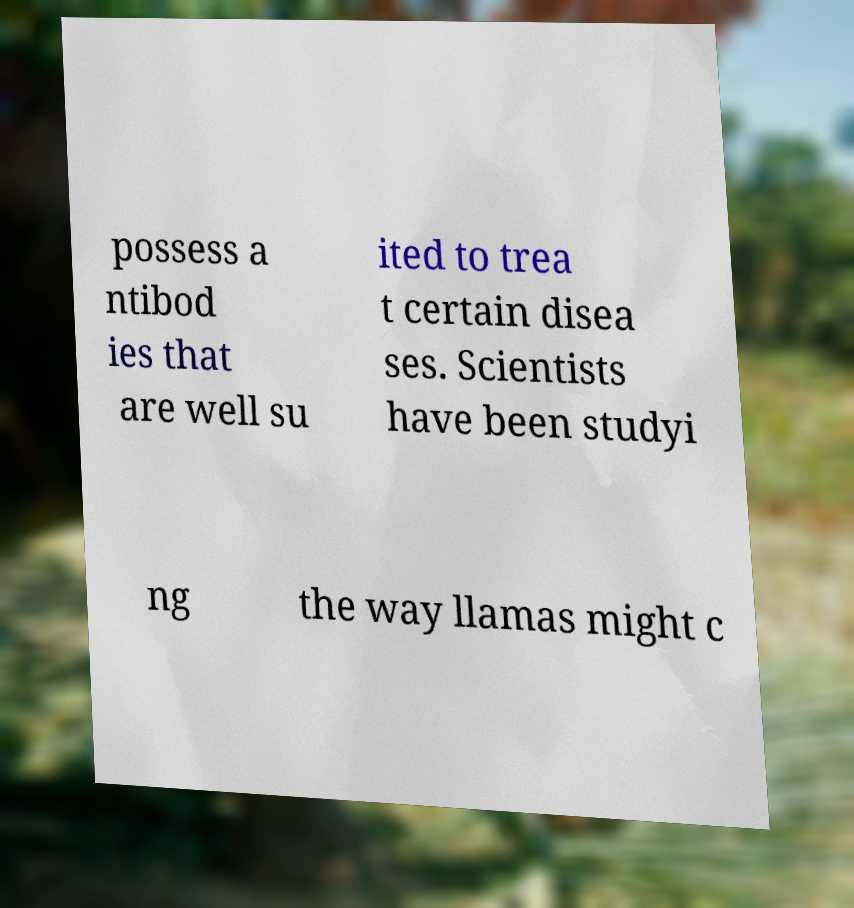Please read and relay the text visible in this image. What does it say? possess a ntibod ies that are well su ited to trea t certain disea ses. Scientists have been studyi ng the way llamas might c 